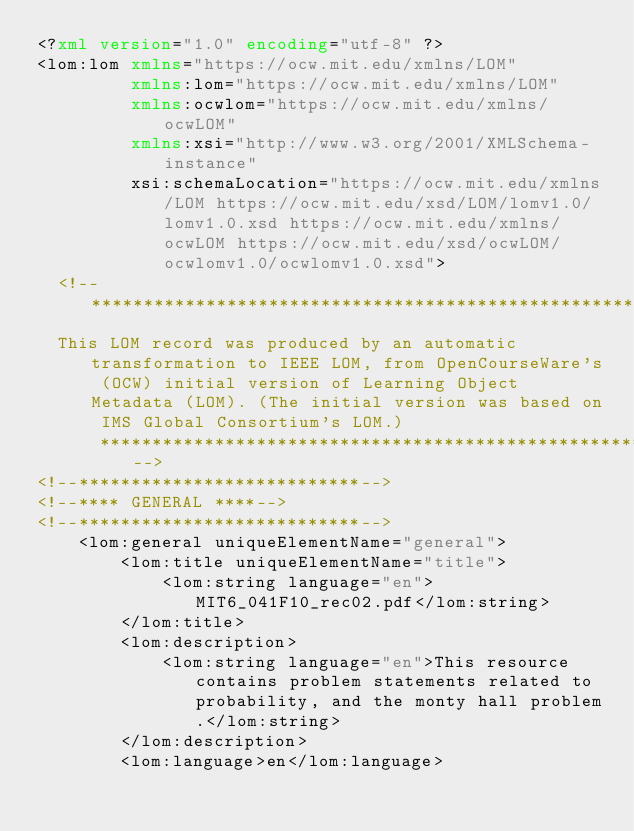<code> <loc_0><loc_0><loc_500><loc_500><_XML_><?xml version="1.0" encoding="utf-8" ?>
<lom:lom xmlns="https://ocw.mit.edu/xmlns/LOM"
         xmlns:lom="https://ocw.mit.edu/xmlns/LOM"
         xmlns:ocwlom="https://ocw.mit.edu/xmlns/ocwLOM"
         xmlns:xsi="http://www.w3.org/2001/XMLSchema-instance"
         xsi:schemaLocation="https://ocw.mit.edu/xmlns/LOM https://ocw.mit.edu/xsd/LOM/lomv1.0/lomv1.0.xsd https://ocw.mit.edu/xmlns/ocwLOM https://ocw.mit.edu/xsd/ocwLOM/ocwlomv1.0/ocwlomv1.0.xsd">
  <!--************************************************************ 
  This LOM record was produced by an automatic transformation to IEEE LOM, from OpenCourseWare's (OCW) initial version of Learning Object Metadata (LOM). (The initial version was based on IMS Global Consortium's LOM.)
			********************************************************-->
<!--***************************-->
<!--**** GENERAL ****-->
<!--***************************-->
    <lom:general uniqueElementName="general">
        <lom:title uniqueElementName="title">
            <lom:string language="en">MIT6_041F10_rec02.pdf</lom:string>
        </lom:title>
        <lom:description>
            <lom:string language="en">This resource contains problem statements related to probability, and the monty hall problem.</lom:string>
        </lom:description>
        <lom:language>en</lom:language></code> 